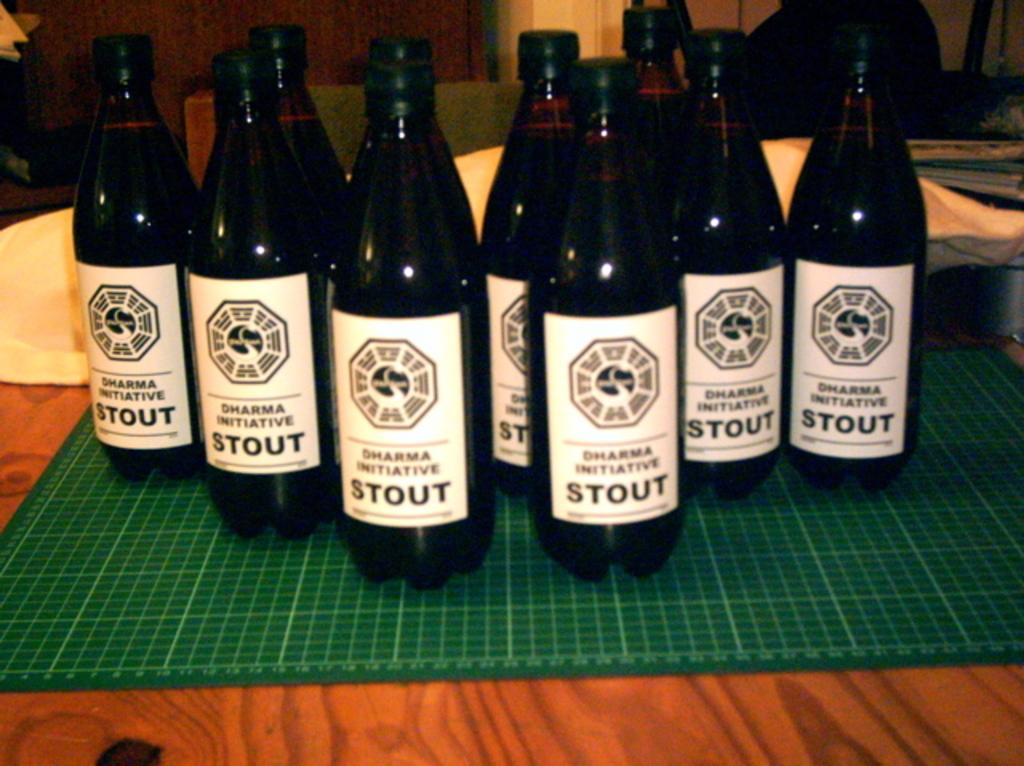What type of objects can be seen in the image? There are bottles in the image. What is the surface made of that the bottles are on? There is a wooden surface in the image. Are there any additional items or features on the bottles? Stickers are on the bottles. What year is depicted on the stickers on the bottles? There is no year mentioned on the stickers in the image. How fast do the bottles run in the image? The bottles do not run in the image; they are stationary objects. 